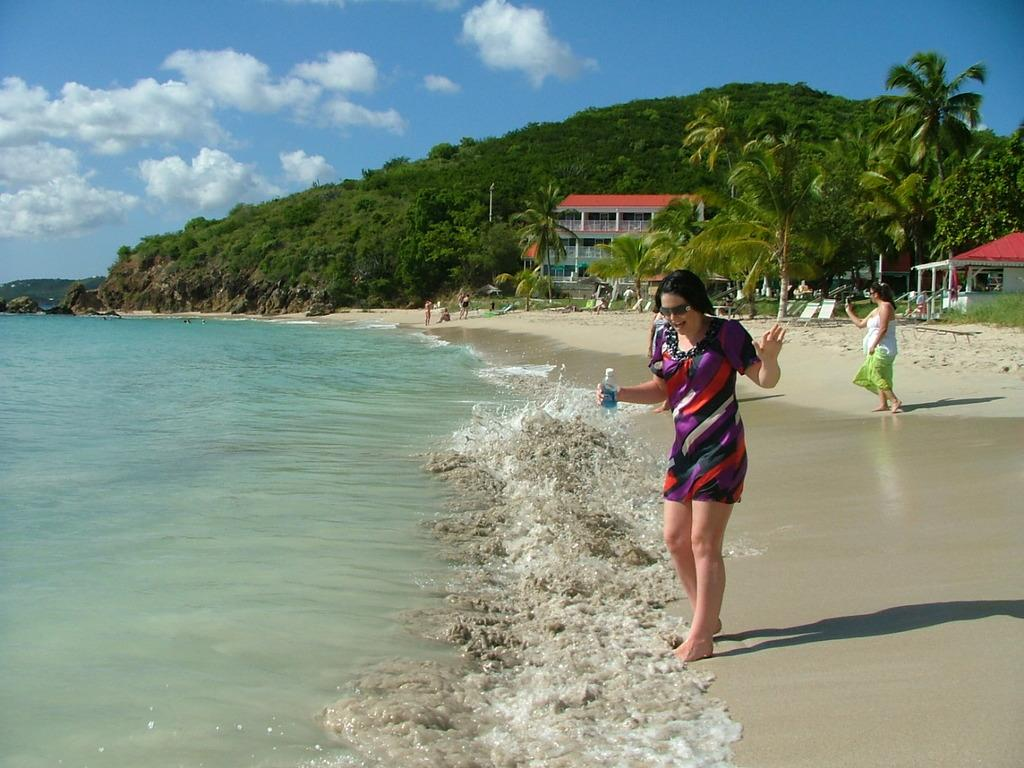What is the woman in the image holding? The woman is holding a water bottle. Where is the woman standing in the image? The woman is standing at the sea. Can you describe the background of the image? In the background of the image, there are buildings, trees, sand, a hill, and the sky. How many people are visible in the image? There is one person visible in the image, the woman holding the water bottle, and another person visible in the background. What is the weather like in the image? The sky is visible in the background of the image, and clouds are present, suggesting that it might be partly cloudy. What type of quince is the woman eating in the image? There is no quince present in the image; the woman is holding a water bottle. What does the stranger desire in the image? There is no stranger present in the image, so it is not possible to determine what they might desire. 